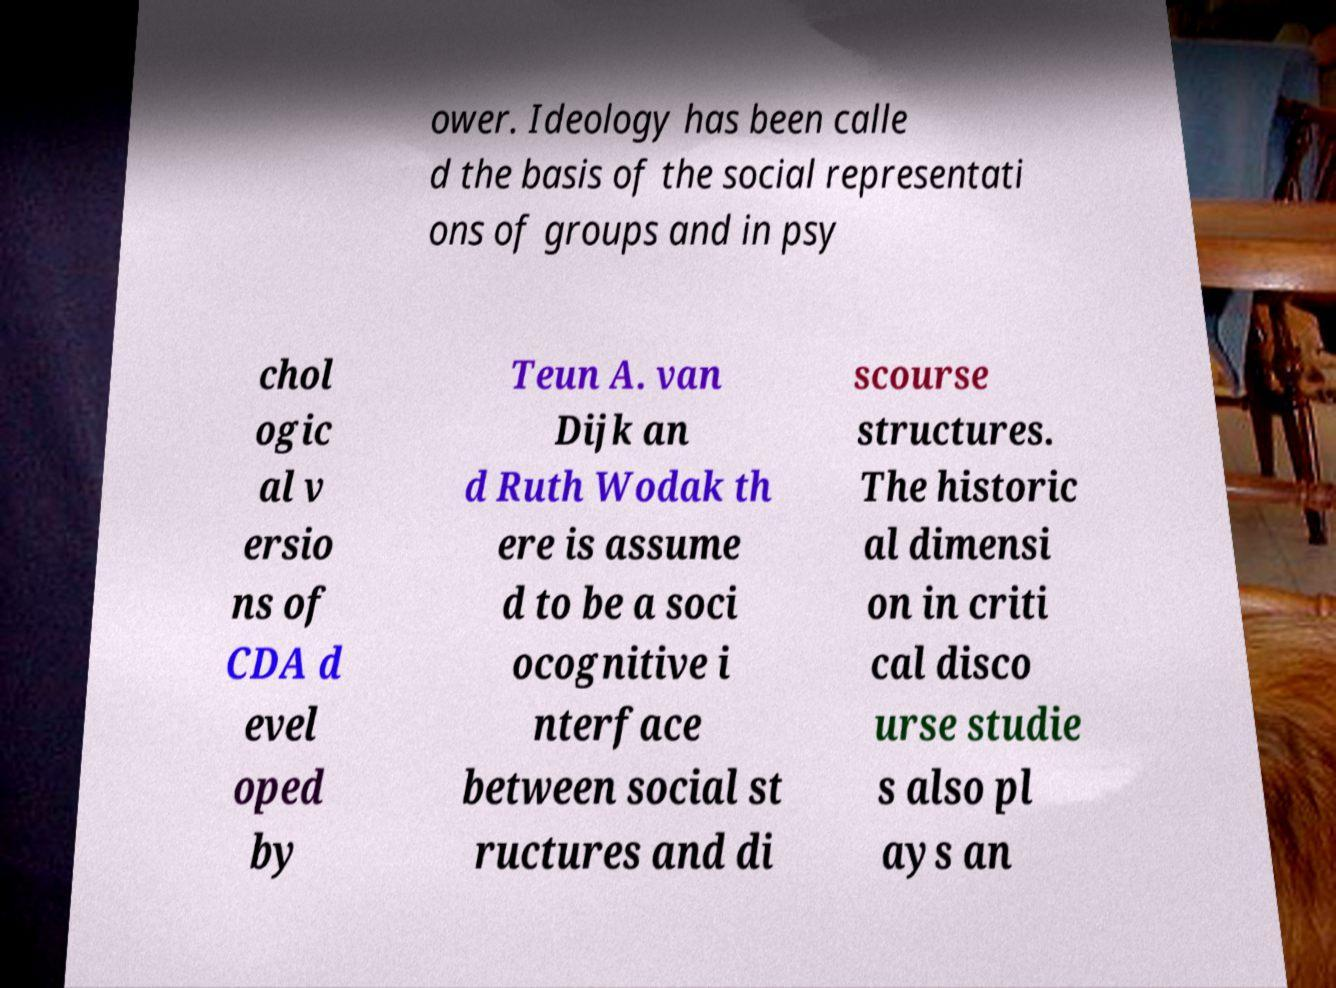There's text embedded in this image that I need extracted. Can you transcribe it verbatim? ower. Ideology has been calle d the basis of the social representati ons of groups and in psy chol ogic al v ersio ns of CDA d evel oped by Teun A. van Dijk an d Ruth Wodak th ere is assume d to be a soci ocognitive i nterface between social st ructures and di scourse structures. The historic al dimensi on in criti cal disco urse studie s also pl ays an 